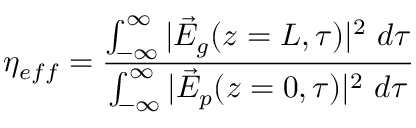<formula> <loc_0><loc_0><loc_500><loc_500>\eta _ { e f f } = \frac { \int _ { - \infty } ^ { \infty } | \vec { E } _ { g } ( z = L , \tau ) | ^ { 2 } d \tau } { \int _ { - \infty } ^ { \infty } | \vec { E } _ { p } ( z = 0 , \tau ) | ^ { 2 } d \tau }</formula> 